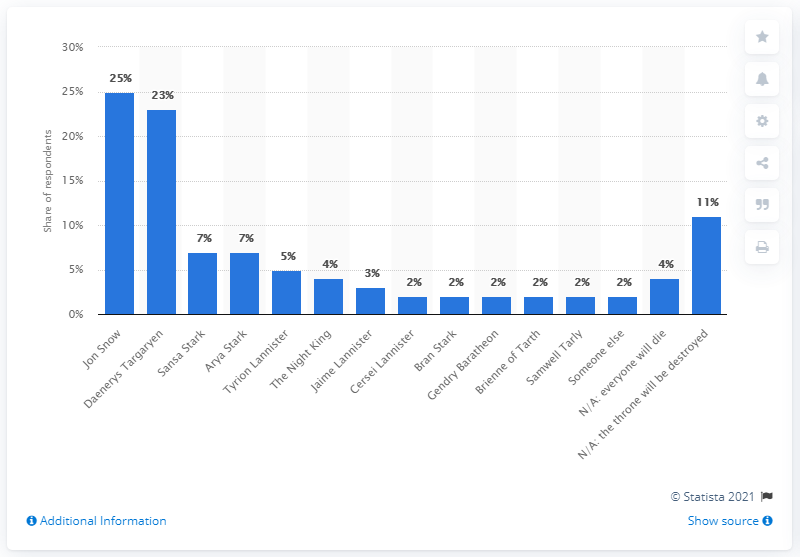Point out several critical features in this image. Jon Snow was the person that 25% of the people who were fully caught up on the show believed would end up on the Iron Throne, as declared by the majority of the viewers. 